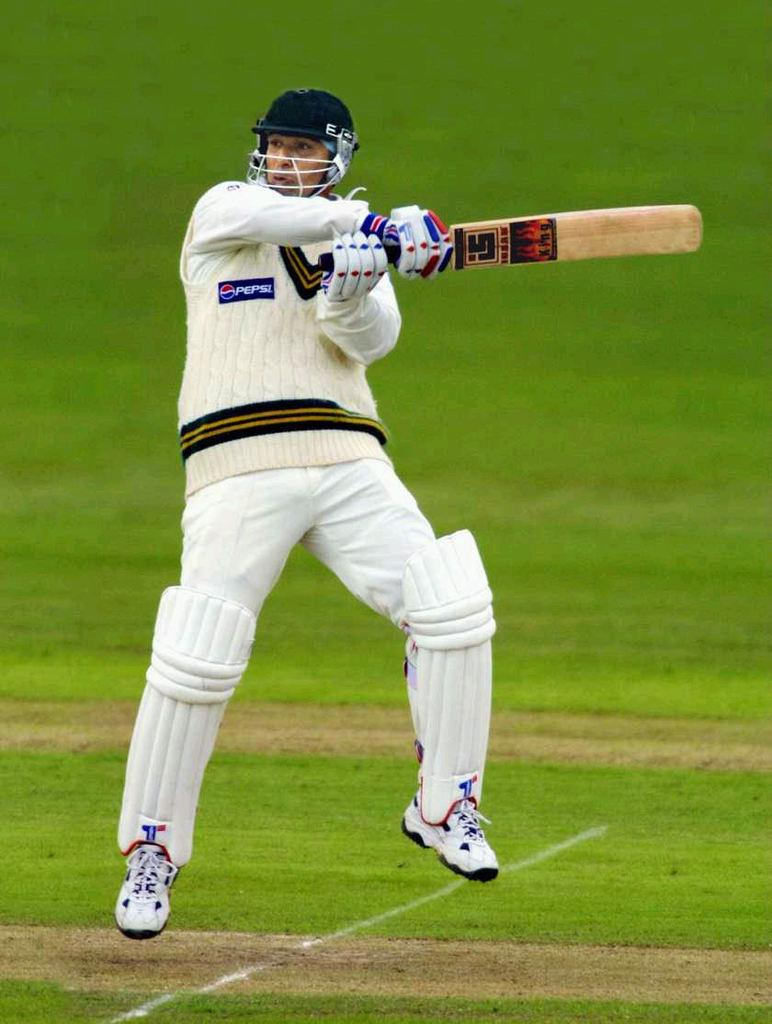What is the man in the image holding? The man is holding a cricket bat. What action is the man performing in the image? The man is jumping. What sport is the man likely participating in? The man is likely playing cricket. What protective gear is the man wearing? The man is wearing a helmet, leg guards, and batting gloves. What type of clothing is the man wearing? The man is wearing a T-shirt, trousers, and shoes. What can be seen in the background of the image? There is grass visible in the image. How many horses are present in the image? There are no horses present in the image. What level of comfort does the man appear to have while playing cricket? The image does not provide information about the man's comfort level while playing cricket. 